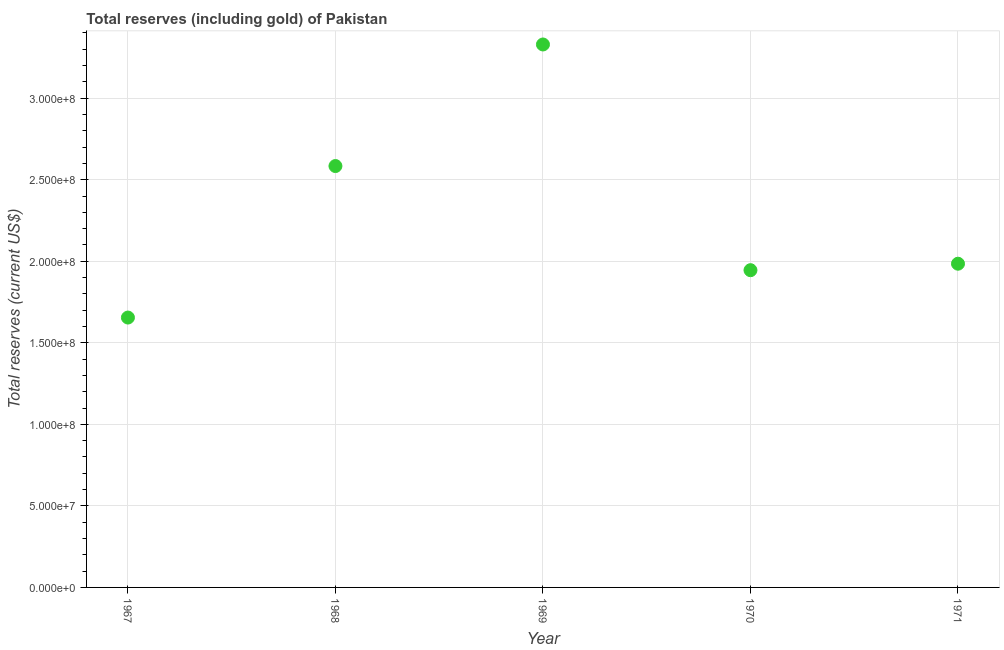What is the total reserves (including gold) in 1971?
Your response must be concise. 1.99e+08. Across all years, what is the maximum total reserves (including gold)?
Keep it short and to the point. 3.33e+08. Across all years, what is the minimum total reserves (including gold)?
Make the answer very short. 1.65e+08. In which year was the total reserves (including gold) maximum?
Provide a short and direct response. 1969. In which year was the total reserves (including gold) minimum?
Provide a short and direct response. 1967. What is the sum of the total reserves (including gold)?
Provide a short and direct response. 1.15e+09. What is the difference between the total reserves (including gold) in 1967 and 1971?
Ensure brevity in your answer.  -3.30e+07. What is the average total reserves (including gold) per year?
Provide a succinct answer. 2.30e+08. What is the median total reserves (including gold)?
Keep it short and to the point. 1.99e+08. In how many years, is the total reserves (including gold) greater than 130000000 US$?
Make the answer very short. 5. What is the ratio of the total reserves (including gold) in 1968 to that in 1971?
Provide a short and direct response. 1.3. Is the total reserves (including gold) in 1967 less than that in 1971?
Your answer should be compact. Yes. Is the difference between the total reserves (including gold) in 1970 and 1971 greater than the difference between any two years?
Your answer should be compact. No. What is the difference between the highest and the second highest total reserves (including gold)?
Offer a terse response. 7.45e+07. Is the sum of the total reserves (including gold) in 1969 and 1971 greater than the maximum total reserves (including gold) across all years?
Keep it short and to the point. Yes. What is the difference between the highest and the lowest total reserves (including gold)?
Offer a very short reply. 1.67e+08. In how many years, is the total reserves (including gold) greater than the average total reserves (including gold) taken over all years?
Give a very brief answer. 2. Does the total reserves (including gold) monotonically increase over the years?
Give a very brief answer. No. How many years are there in the graph?
Keep it short and to the point. 5. What is the difference between two consecutive major ticks on the Y-axis?
Keep it short and to the point. 5.00e+07. Does the graph contain any zero values?
Your response must be concise. No. Does the graph contain grids?
Keep it short and to the point. Yes. What is the title of the graph?
Ensure brevity in your answer.  Total reserves (including gold) of Pakistan. What is the label or title of the Y-axis?
Make the answer very short. Total reserves (current US$). What is the Total reserves (current US$) in 1967?
Offer a very short reply. 1.65e+08. What is the Total reserves (current US$) in 1968?
Keep it short and to the point. 2.58e+08. What is the Total reserves (current US$) in 1969?
Keep it short and to the point. 3.33e+08. What is the Total reserves (current US$) in 1970?
Your answer should be very brief. 1.95e+08. What is the Total reserves (current US$) in 1971?
Make the answer very short. 1.99e+08. What is the difference between the Total reserves (current US$) in 1967 and 1968?
Your answer should be compact. -9.29e+07. What is the difference between the Total reserves (current US$) in 1967 and 1969?
Provide a short and direct response. -1.67e+08. What is the difference between the Total reserves (current US$) in 1967 and 1970?
Provide a succinct answer. -2.90e+07. What is the difference between the Total reserves (current US$) in 1967 and 1971?
Offer a very short reply. -3.30e+07. What is the difference between the Total reserves (current US$) in 1968 and 1969?
Keep it short and to the point. -7.45e+07. What is the difference between the Total reserves (current US$) in 1968 and 1970?
Your answer should be very brief. 6.39e+07. What is the difference between the Total reserves (current US$) in 1968 and 1971?
Make the answer very short. 5.99e+07. What is the difference between the Total reserves (current US$) in 1969 and 1970?
Offer a terse response. 1.38e+08. What is the difference between the Total reserves (current US$) in 1969 and 1971?
Offer a terse response. 1.34e+08. What is the difference between the Total reserves (current US$) in 1970 and 1971?
Provide a succinct answer. -3.97e+06. What is the ratio of the Total reserves (current US$) in 1967 to that in 1968?
Provide a succinct answer. 0.64. What is the ratio of the Total reserves (current US$) in 1967 to that in 1969?
Your response must be concise. 0.5. What is the ratio of the Total reserves (current US$) in 1967 to that in 1970?
Your answer should be very brief. 0.85. What is the ratio of the Total reserves (current US$) in 1967 to that in 1971?
Give a very brief answer. 0.83. What is the ratio of the Total reserves (current US$) in 1968 to that in 1969?
Provide a short and direct response. 0.78. What is the ratio of the Total reserves (current US$) in 1968 to that in 1970?
Keep it short and to the point. 1.33. What is the ratio of the Total reserves (current US$) in 1968 to that in 1971?
Your response must be concise. 1.3. What is the ratio of the Total reserves (current US$) in 1969 to that in 1970?
Provide a succinct answer. 1.71. What is the ratio of the Total reserves (current US$) in 1969 to that in 1971?
Keep it short and to the point. 1.68. What is the ratio of the Total reserves (current US$) in 1970 to that in 1971?
Your answer should be compact. 0.98. 